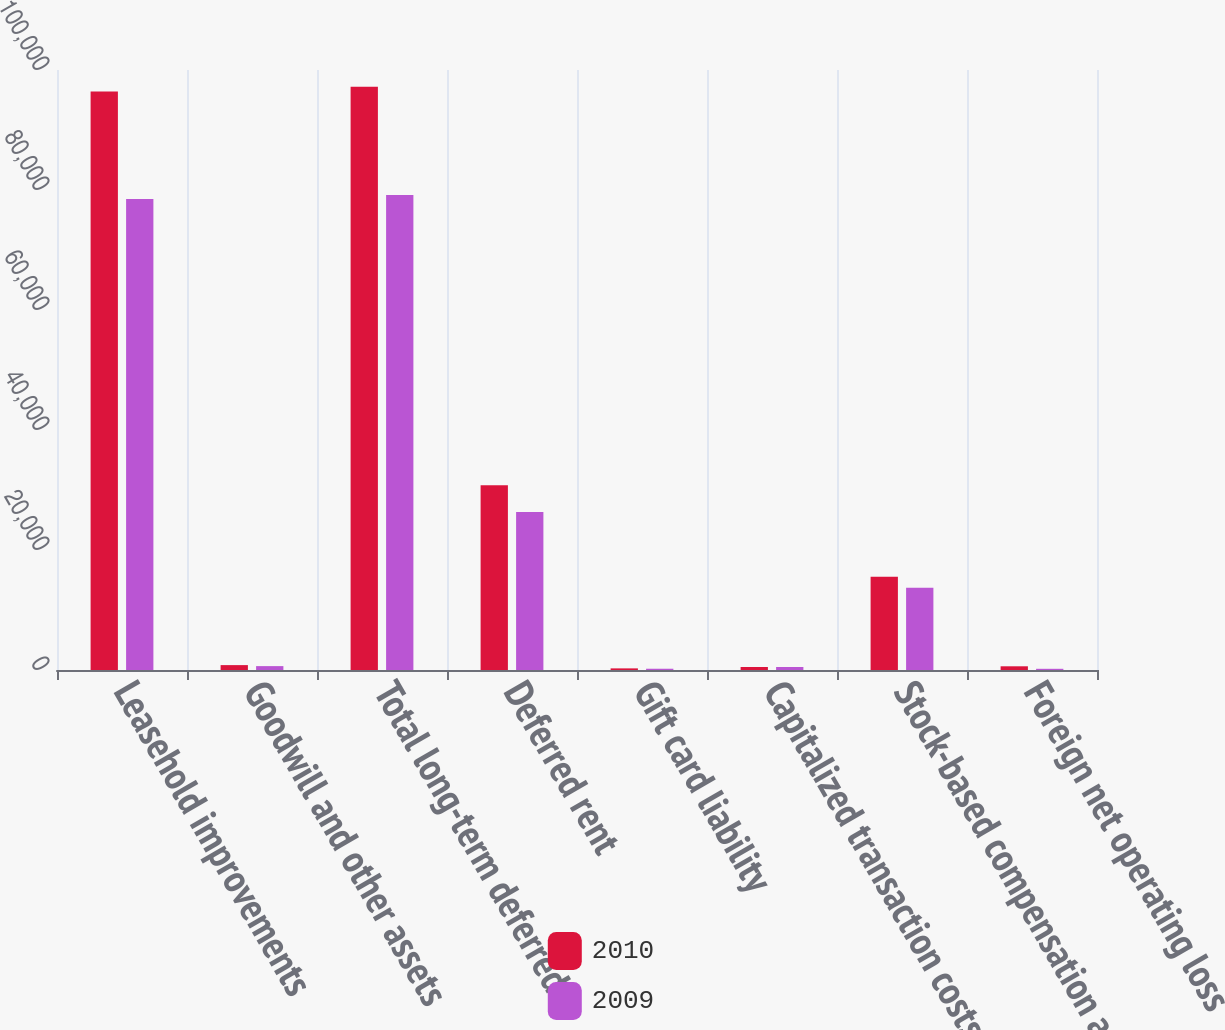Convert chart to OTSL. <chart><loc_0><loc_0><loc_500><loc_500><stacked_bar_chart><ecel><fcel>Leasehold improvements<fcel>Goodwill and other assets<fcel>Total long-term deferred<fcel>Deferred rent<fcel>Gift card liability<fcel>Capitalized transaction costs<fcel>Stock-based compensation and<fcel>Foreign net operating loss<nl><fcel>2010<fcel>96399<fcel>815<fcel>97214<fcel>30806<fcel>271<fcel>502<fcel>15548<fcel>617<nl><fcel>2009<fcel>78504<fcel>647<fcel>79151<fcel>26319<fcel>210<fcel>503<fcel>13696<fcel>200<nl></chart> 